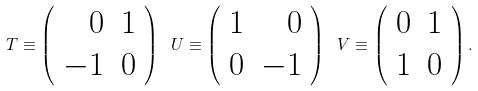Convert formula to latex. <formula><loc_0><loc_0><loc_500><loc_500>T \equiv \left ( \begin{array} { r r } 0 & 1 \\ - 1 & 0 \end{array} \right ) \ U \equiv \left ( \begin{array} { r r } 1 & 0 \\ 0 & - 1 \end{array} \right ) \ V \equiv \left ( \begin{array} { r r } 0 & 1 \\ 1 & 0 \end{array} \right ) .</formula> 